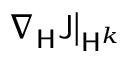<formula> <loc_0><loc_0><loc_500><loc_500>\nabla _ { H } J \right | _ { H ^ { k } }</formula> 